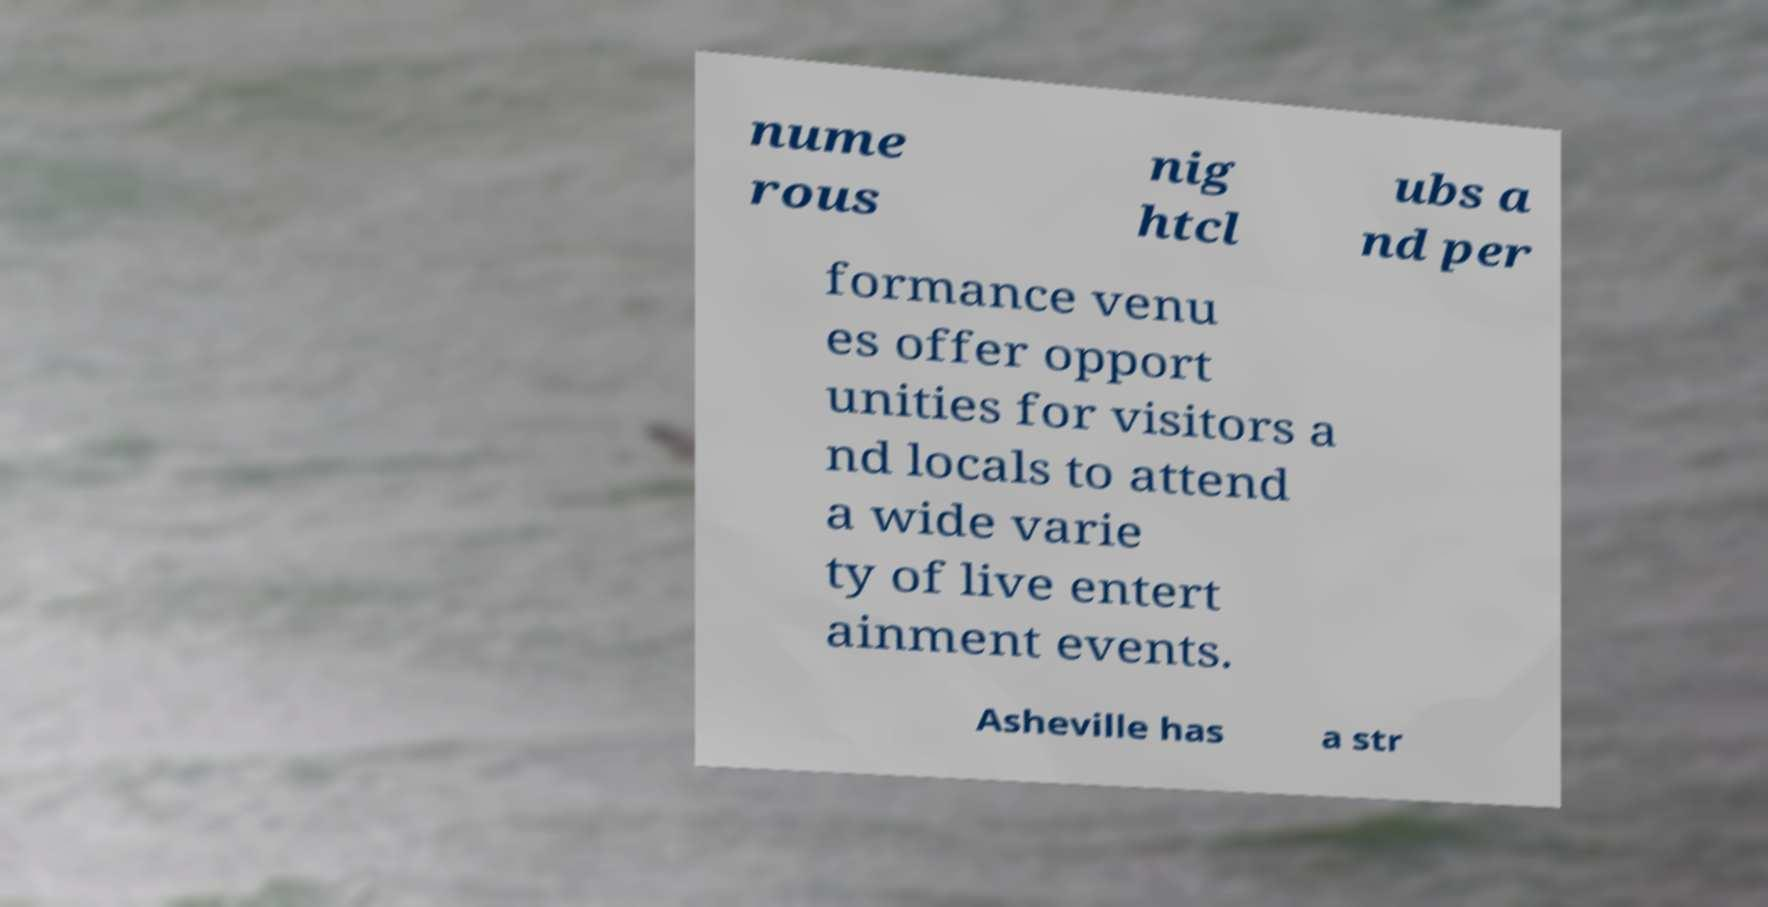Could you assist in decoding the text presented in this image and type it out clearly? nume rous nig htcl ubs a nd per formance venu es offer opport unities for visitors a nd locals to attend a wide varie ty of live entert ainment events. Asheville has a str 